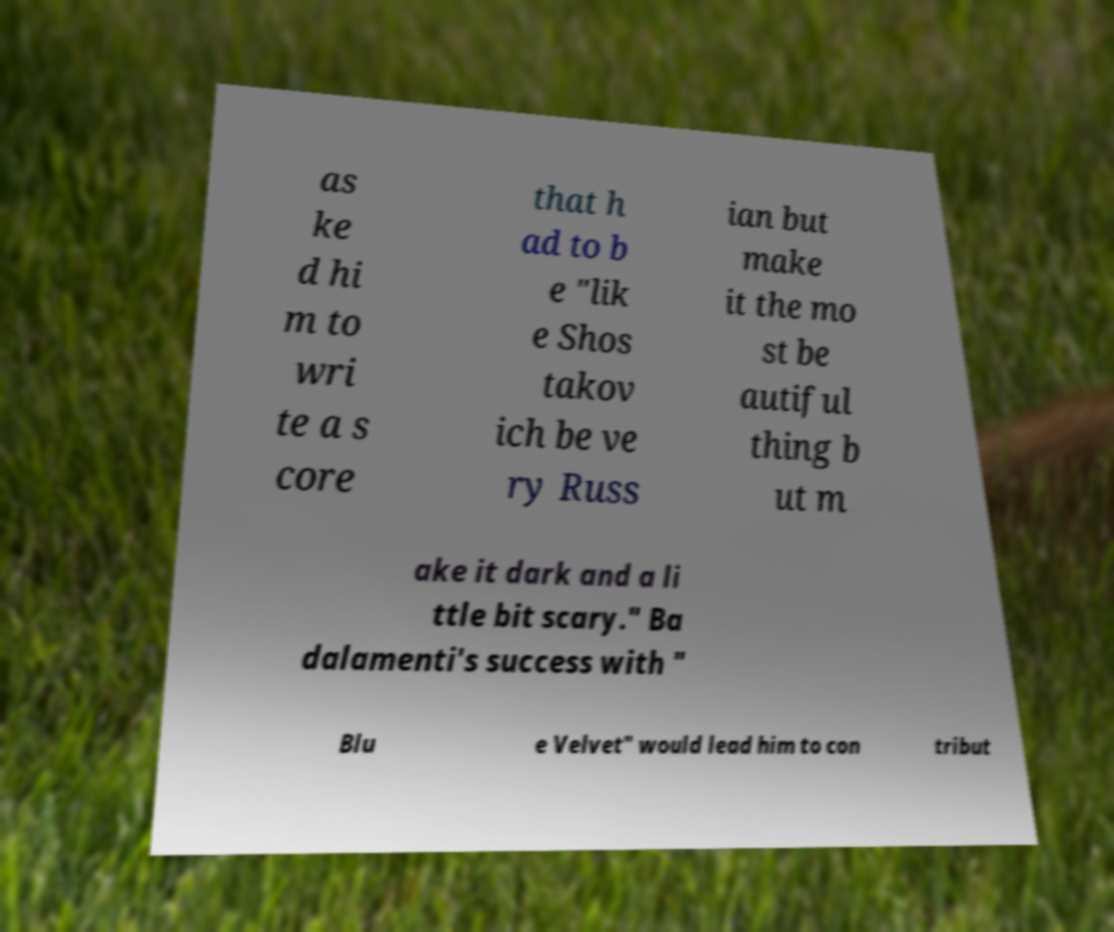Can you accurately transcribe the text from the provided image for me? as ke d hi m to wri te a s core that h ad to b e "lik e Shos takov ich be ve ry Russ ian but make it the mo st be autiful thing b ut m ake it dark and a li ttle bit scary." Ba dalamenti's success with " Blu e Velvet" would lead him to con tribut 